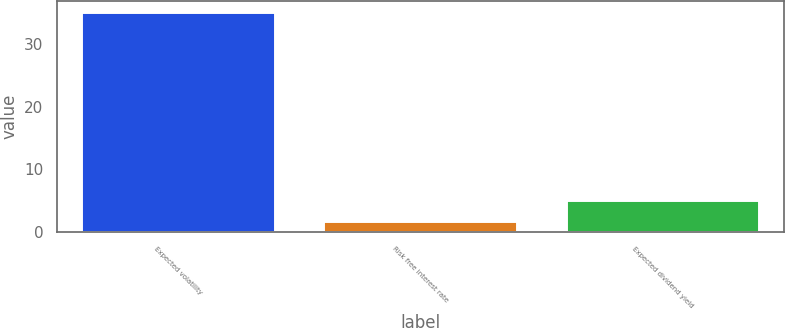Convert chart. <chart><loc_0><loc_0><loc_500><loc_500><bar_chart><fcel>Expected volatility<fcel>Risk free interest rate<fcel>Expected dividend yield<nl><fcel>35<fcel>1.76<fcel>5.08<nl></chart> 